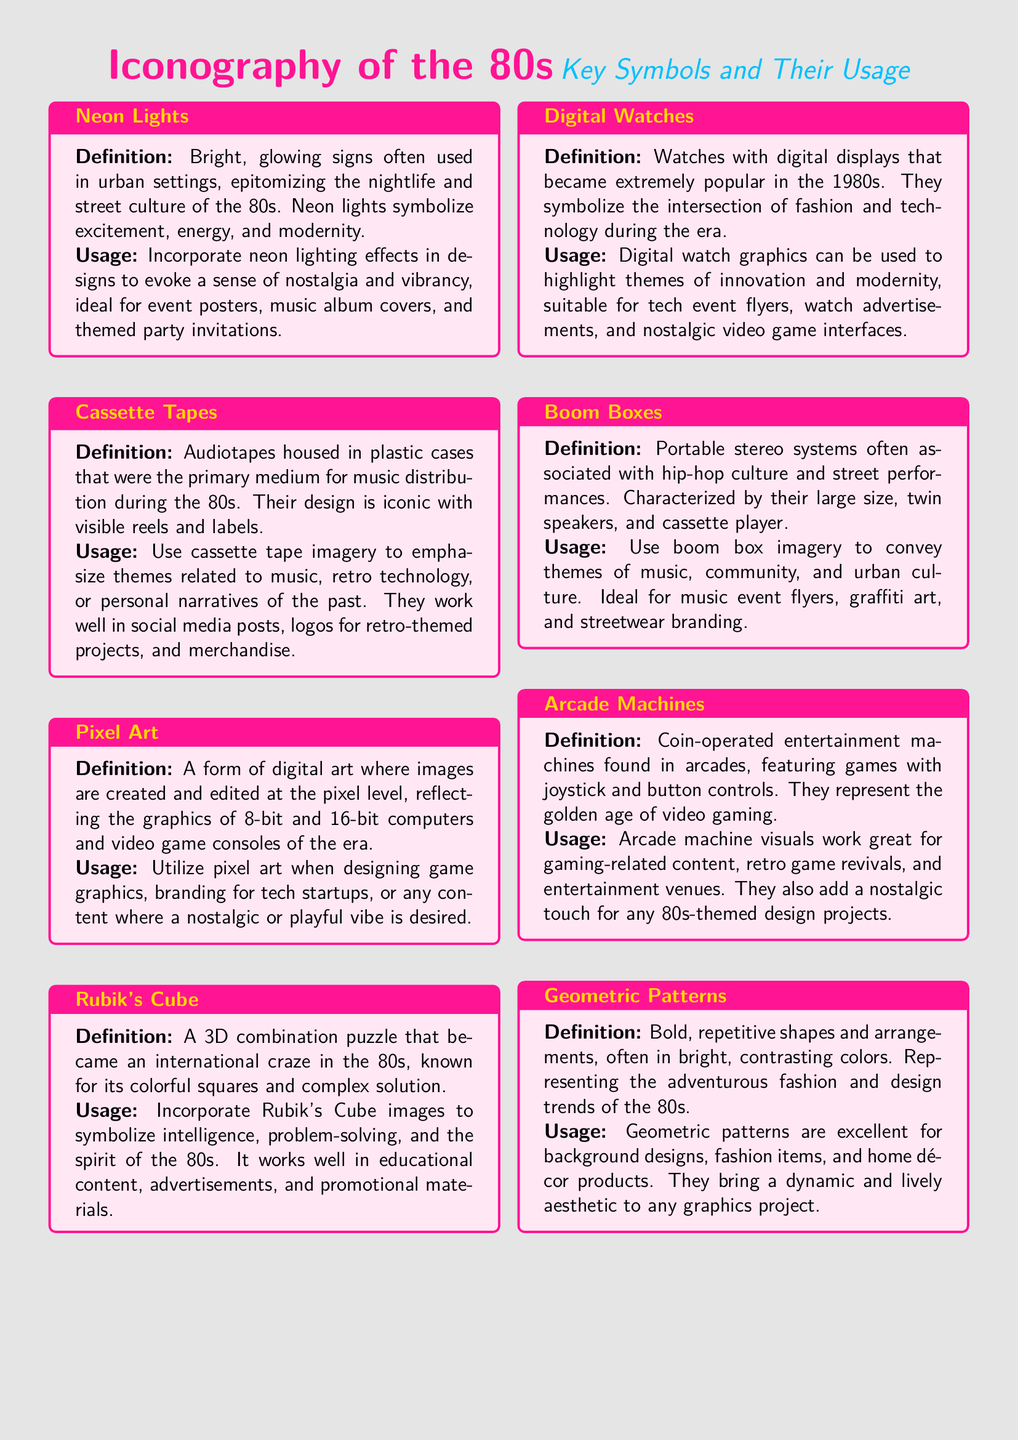What is the definition of Neon Lights? Neon Lights are defined as bright, glowing signs often used in urban settings, epitomizing the nightlife and street culture of the 80s.
Answer: Bright, glowing signs What does the term Pixel Art refer to? Pixel Art refers to a form of digital art where images are created and edited at the pixel level, reflecting the graphics of 8-bit and 16-bit computers and video game consoles of the era.
Answer: Form of digital art Which key symbol is associated with hip-hop culture? The key symbol associated with hip-hop culture is the Boom Box, a portable stereo system often linked to street performances.
Answer: Boom Box How can Digital Watches be used in design? Digital Watches can be used to highlight themes of innovation and modernity, suitable for tech event flyers.
Answer: Highlight themes of innovation What pattern design is representative of the adventurous fashion trends of the 80s? The pattern design that represents these trends is Geometric Patterns, characterized by bold, repetitive shapes.
Answer: Geometric Patterns Which iconic item became an international craze in the 80s? The iconic item that became an international craze is Rubik's Cube, a 3D combination puzzle known for its colorful squares.
Answer: Rubik's Cube What type of imagery should be used for retro-themed projects? Cassette Tape imagery should be used for retro-themed projects, emphasizing music and retro technology.
Answer: Cassette Tape imagery What is the usage of Arcade Machines in design? Arcade Machines visuals work great for gaming-related content and retro game revivals.
Answer: Gaming-related content 